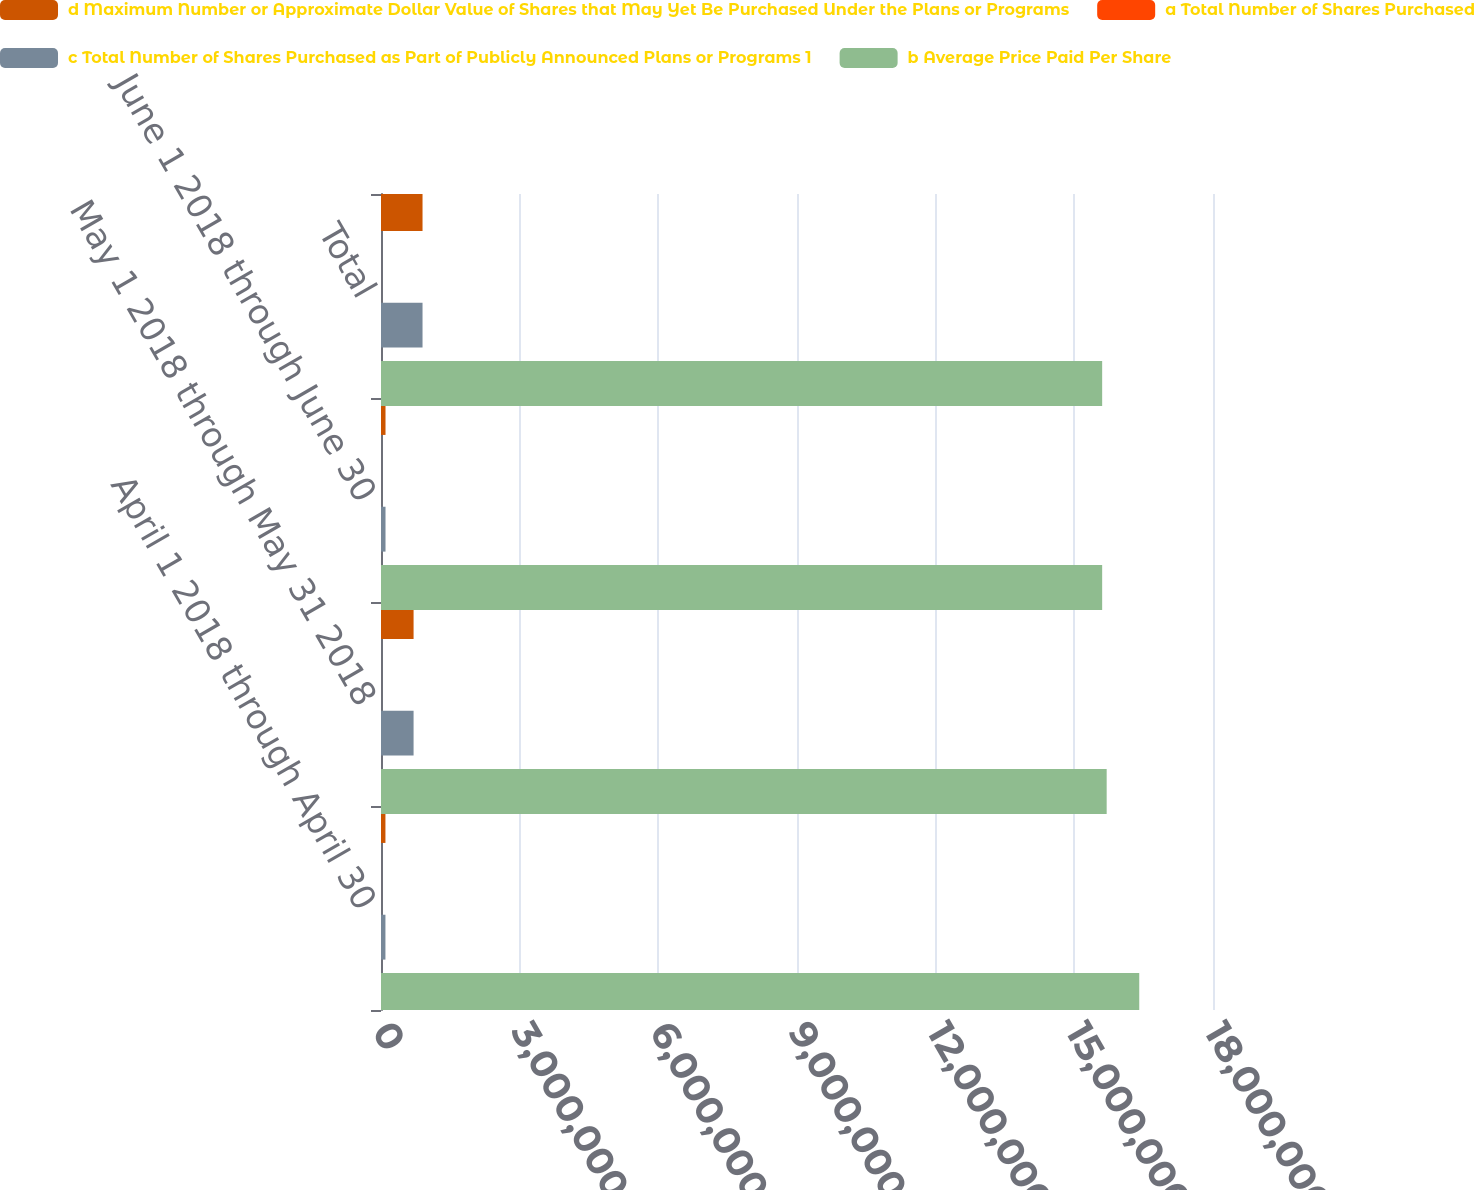Convert chart. <chart><loc_0><loc_0><loc_500><loc_500><stacked_bar_chart><ecel><fcel>April 1 2018 through April 30<fcel>May 1 2018 through May 31 2018<fcel>June 1 2018 through June 30<fcel>Total<nl><fcel>d Maximum Number or Approximate Dollar Value of Shares that May Yet Be Purchased Under the Plans or Programs<fcel>96100<fcel>704770<fcel>97647<fcel>898517<nl><fcel>a Total Number of Shares Purchased<fcel>170.96<fcel>166.21<fcel>168.11<fcel>166.92<nl><fcel>c Total Number of Shares Purchased as Part of Publicly Announced Plans or Programs 1<fcel>96100<fcel>704770<fcel>97647<fcel>898517<nl><fcel>b Average Price Paid Per Share<fcel>1.64045e+07<fcel>1.56997e+07<fcel>1.56021e+07<fcel>1.56021e+07<nl></chart> 